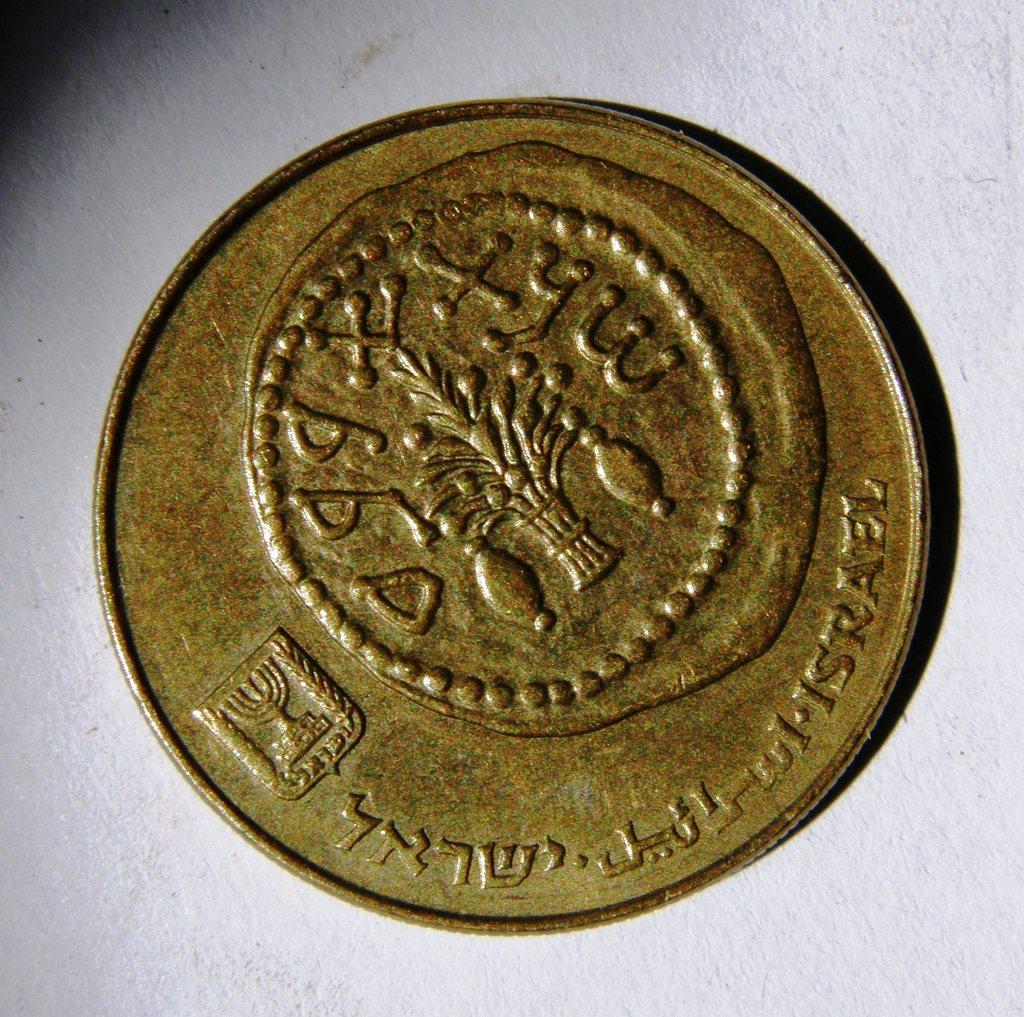<image>
Give a short and clear explanation of the subsequent image. a coin that has some foreign language on it 